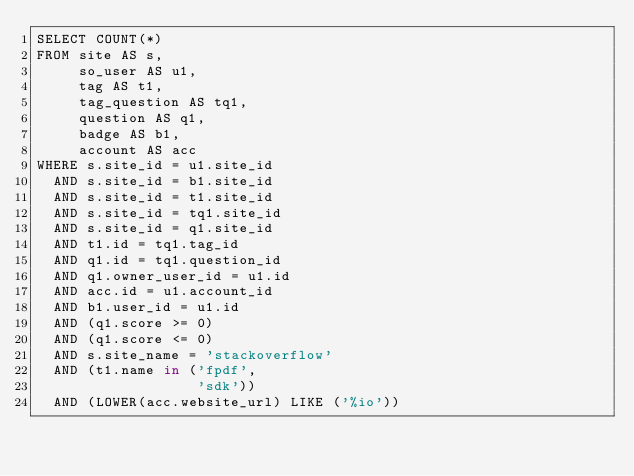Convert code to text. <code><loc_0><loc_0><loc_500><loc_500><_SQL_>SELECT COUNT(*)
FROM site AS s,
     so_user AS u1,
     tag AS t1,
     tag_question AS tq1,
     question AS q1,
     badge AS b1,
     account AS acc
WHERE s.site_id = u1.site_id
  AND s.site_id = b1.site_id
  AND s.site_id = t1.site_id
  AND s.site_id = tq1.site_id
  AND s.site_id = q1.site_id
  AND t1.id = tq1.tag_id
  AND q1.id = tq1.question_id
  AND q1.owner_user_id = u1.id
  AND acc.id = u1.account_id
  AND b1.user_id = u1.id
  AND (q1.score >= 0)
  AND (q1.score <= 0)
  AND s.site_name = 'stackoverflow'
  AND (t1.name in ('fpdf',
                   'sdk'))
  AND (LOWER(acc.website_url) LIKE ('%io'))</code> 